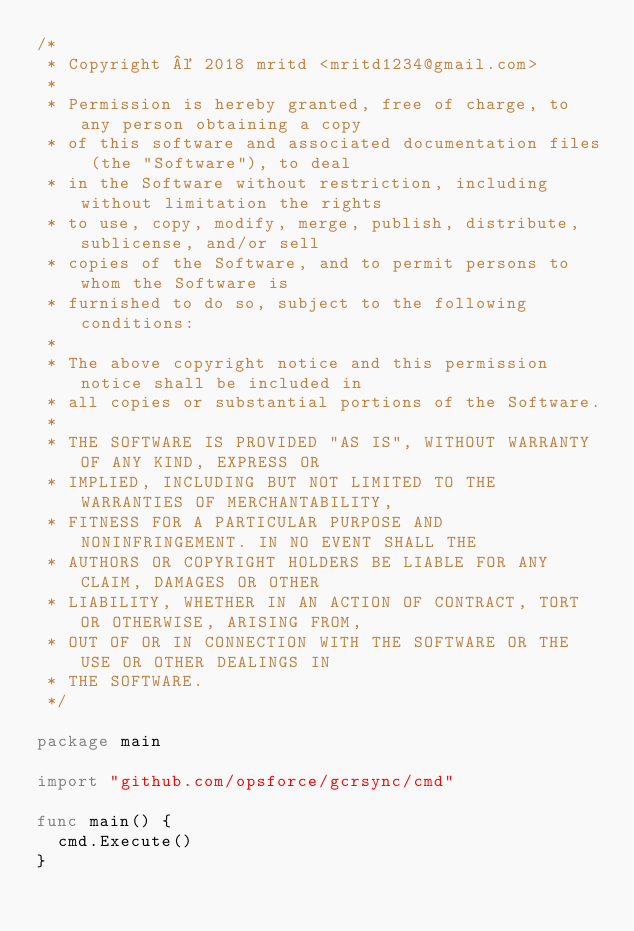Convert code to text. <code><loc_0><loc_0><loc_500><loc_500><_Go_>/*
 * Copyright © 2018 mritd <mritd1234@gmail.com>
 *
 * Permission is hereby granted, free of charge, to any person obtaining a copy
 * of this software and associated documentation files (the "Software"), to deal
 * in the Software without restriction, including without limitation the rights
 * to use, copy, modify, merge, publish, distribute, sublicense, and/or sell
 * copies of the Software, and to permit persons to whom the Software is
 * furnished to do so, subject to the following conditions:
 *
 * The above copyright notice and this permission notice shall be included in
 * all copies or substantial portions of the Software.
 *
 * THE SOFTWARE IS PROVIDED "AS IS", WITHOUT WARRANTY OF ANY KIND, EXPRESS OR
 * IMPLIED, INCLUDING BUT NOT LIMITED TO THE WARRANTIES OF MERCHANTABILITY,
 * FITNESS FOR A PARTICULAR PURPOSE AND NONINFRINGEMENT. IN NO EVENT SHALL THE
 * AUTHORS OR COPYRIGHT HOLDERS BE LIABLE FOR ANY CLAIM, DAMAGES OR OTHER
 * LIABILITY, WHETHER IN AN ACTION OF CONTRACT, TORT OR OTHERWISE, ARISING FROM,
 * OUT OF OR IN CONNECTION WITH THE SOFTWARE OR THE USE OR OTHER DEALINGS IN
 * THE SOFTWARE.
 */

package main

import "github.com/opsforce/gcrsync/cmd"

func main() {
	cmd.Execute()
}
</code> 